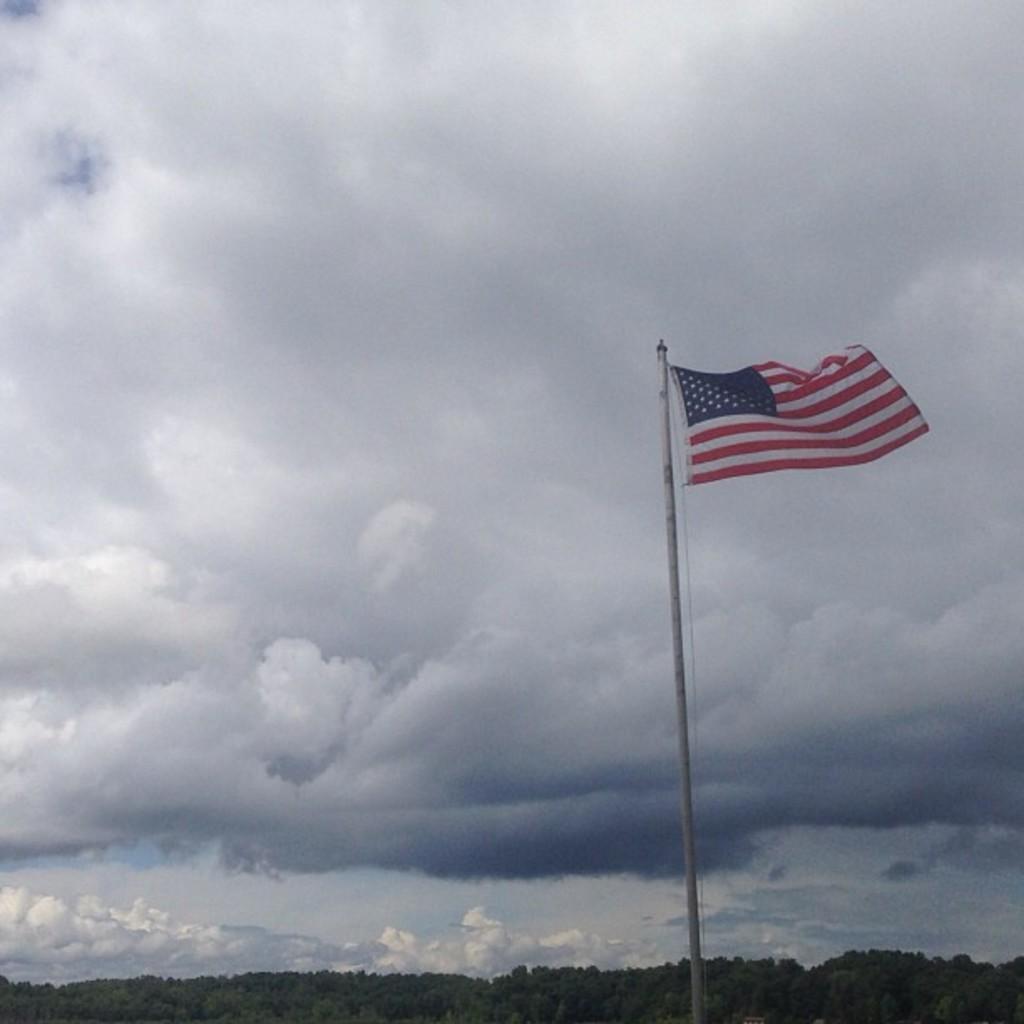Could you give a brief overview of what you see in this image? In this image there is a flag to a pole. At the bottom there are trees. At the top there is the sky. The sky is cloudy. 